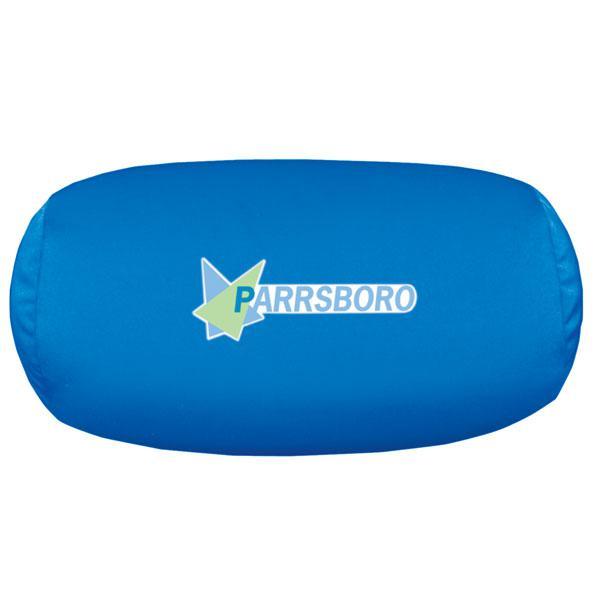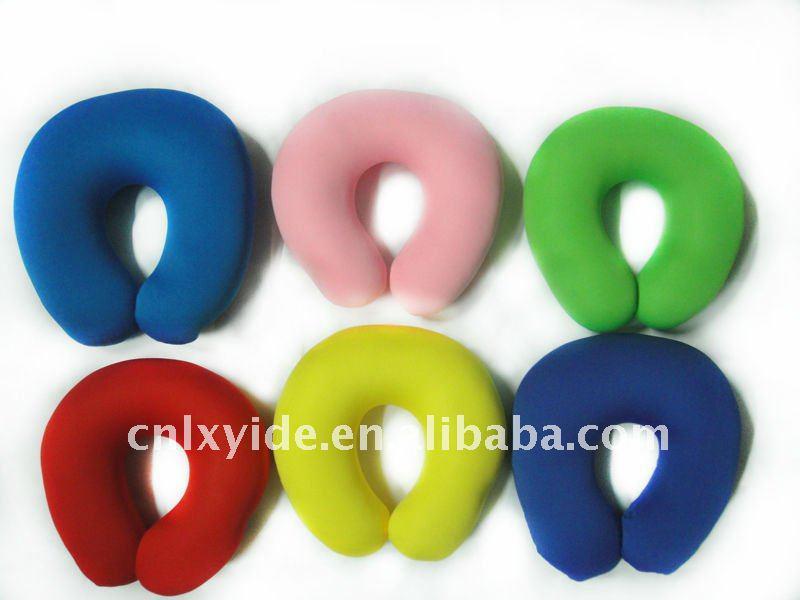The first image is the image on the left, the second image is the image on the right. Examine the images to the left and right. Is the description "The left image has a neck pillow in a cylindrical shape." accurate? Answer yes or no. Yes. The first image is the image on the left, the second image is the image on the right. Evaluate the accuracy of this statement regarding the images: "The left image contains one oblong blue pillow, and the right image includes a bright blue horseshoe-shaped pillow.". Is it true? Answer yes or no. Yes. 